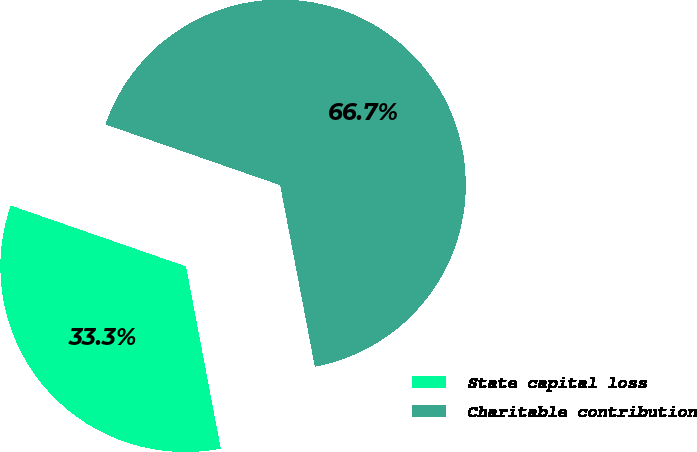Convert chart to OTSL. <chart><loc_0><loc_0><loc_500><loc_500><pie_chart><fcel>State capital loss<fcel>Charitable contribution<nl><fcel>33.33%<fcel>66.67%<nl></chart> 